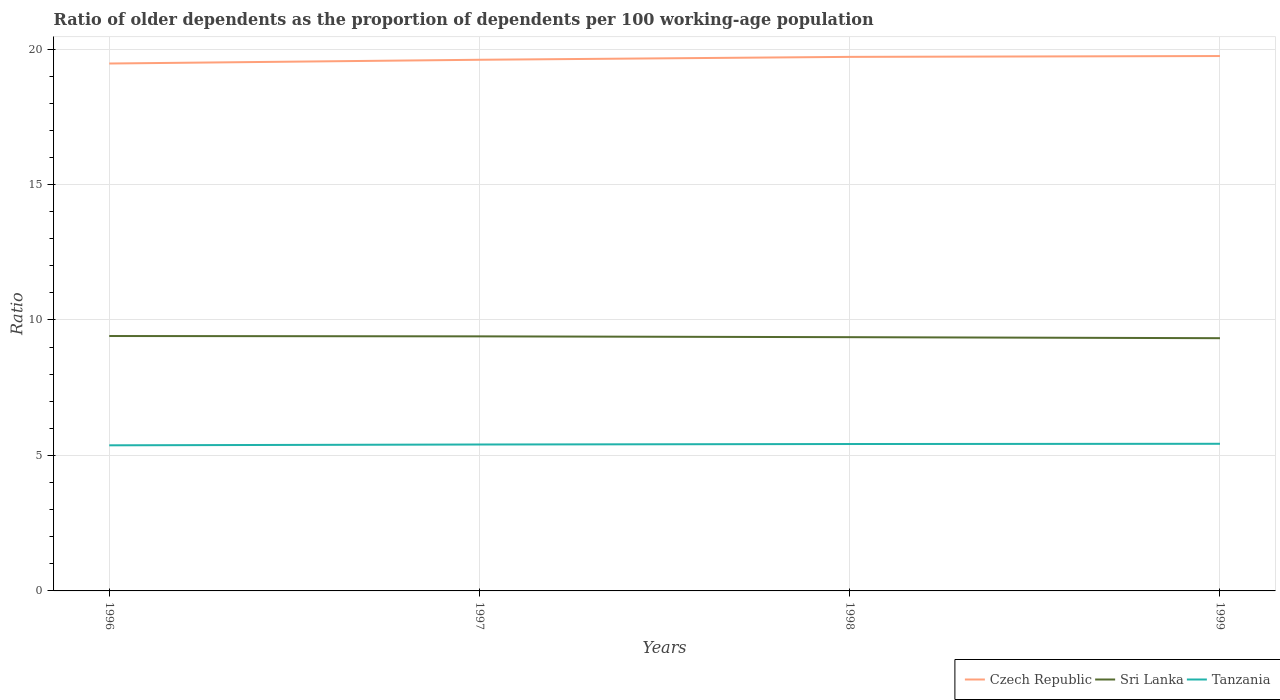How many different coloured lines are there?
Your answer should be very brief. 3. Is the number of lines equal to the number of legend labels?
Your answer should be compact. Yes. Across all years, what is the maximum age dependency ratio(old) in Sri Lanka?
Your answer should be compact. 9.33. What is the total age dependency ratio(old) in Sri Lanka in the graph?
Give a very brief answer. 0.04. What is the difference between the highest and the second highest age dependency ratio(old) in Tanzania?
Provide a short and direct response. 0.06. How many years are there in the graph?
Offer a very short reply. 4. What is the difference between two consecutive major ticks on the Y-axis?
Offer a terse response. 5. Are the values on the major ticks of Y-axis written in scientific E-notation?
Give a very brief answer. No. Does the graph contain any zero values?
Make the answer very short. No. How many legend labels are there?
Ensure brevity in your answer.  3. How are the legend labels stacked?
Provide a succinct answer. Horizontal. What is the title of the graph?
Keep it short and to the point. Ratio of older dependents as the proportion of dependents per 100 working-age population. What is the label or title of the X-axis?
Your response must be concise. Years. What is the label or title of the Y-axis?
Offer a very short reply. Ratio. What is the Ratio of Czech Republic in 1996?
Keep it short and to the point. 19.47. What is the Ratio in Sri Lanka in 1996?
Ensure brevity in your answer.  9.41. What is the Ratio in Tanzania in 1996?
Make the answer very short. 5.37. What is the Ratio of Czech Republic in 1997?
Make the answer very short. 19.6. What is the Ratio in Sri Lanka in 1997?
Your response must be concise. 9.4. What is the Ratio in Tanzania in 1997?
Your answer should be very brief. 5.4. What is the Ratio of Czech Republic in 1998?
Your answer should be compact. 19.71. What is the Ratio in Sri Lanka in 1998?
Offer a terse response. 9.37. What is the Ratio of Tanzania in 1998?
Your answer should be compact. 5.42. What is the Ratio in Czech Republic in 1999?
Provide a short and direct response. 19.74. What is the Ratio of Sri Lanka in 1999?
Your answer should be very brief. 9.33. What is the Ratio in Tanzania in 1999?
Provide a succinct answer. 5.43. Across all years, what is the maximum Ratio of Czech Republic?
Offer a terse response. 19.74. Across all years, what is the maximum Ratio of Sri Lanka?
Your response must be concise. 9.41. Across all years, what is the maximum Ratio in Tanzania?
Your answer should be very brief. 5.43. Across all years, what is the minimum Ratio in Czech Republic?
Your answer should be very brief. 19.47. Across all years, what is the minimum Ratio of Sri Lanka?
Offer a terse response. 9.33. Across all years, what is the minimum Ratio in Tanzania?
Ensure brevity in your answer.  5.37. What is the total Ratio in Czech Republic in the graph?
Give a very brief answer. 78.52. What is the total Ratio of Sri Lanka in the graph?
Your answer should be compact. 37.5. What is the total Ratio in Tanzania in the graph?
Give a very brief answer. 21.63. What is the difference between the Ratio of Czech Republic in 1996 and that in 1997?
Your answer should be compact. -0.14. What is the difference between the Ratio of Sri Lanka in 1996 and that in 1997?
Your answer should be very brief. 0.01. What is the difference between the Ratio in Tanzania in 1996 and that in 1997?
Your answer should be compact. -0.03. What is the difference between the Ratio in Czech Republic in 1996 and that in 1998?
Offer a terse response. -0.24. What is the difference between the Ratio in Sri Lanka in 1996 and that in 1998?
Your answer should be compact. 0.04. What is the difference between the Ratio in Tanzania in 1996 and that in 1998?
Provide a succinct answer. -0.05. What is the difference between the Ratio in Czech Republic in 1996 and that in 1999?
Make the answer very short. -0.28. What is the difference between the Ratio of Sri Lanka in 1996 and that in 1999?
Your answer should be compact. 0.08. What is the difference between the Ratio in Tanzania in 1996 and that in 1999?
Your answer should be very brief. -0.06. What is the difference between the Ratio in Czech Republic in 1997 and that in 1998?
Offer a very short reply. -0.11. What is the difference between the Ratio of Sri Lanka in 1997 and that in 1998?
Make the answer very short. 0.03. What is the difference between the Ratio of Tanzania in 1997 and that in 1998?
Give a very brief answer. -0.02. What is the difference between the Ratio of Czech Republic in 1997 and that in 1999?
Provide a succinct answer. -0.14. What is the difference between the Ratio of Sri Lanka in 1997 and that in 1999?
Make the answer very short. 0.07. What is the difference between the Ratio in Tanzania in 1997 and that in 1999?
Offer a very short reply. -0.03. What is the difference between the Ratio of Czech Republic in 1998 and that in 1999?
Make the answer very short. -0.03. What is the difference between the Ratio of Sri Lanka in 1998 and that in 1999?
Make the answer very short. 0.04. What is the difference between the Ratio of Tanzania in 1998 and that in 1999?
Your answer should be compact. -0.01. What is the difference between the Ratio in Czech Republic in 1996 and the Ratio in Sri Lanka in 1997?
Your response must be concise. 10.07. What is the difference between the Ratio of Czech Republic in 1996 and the Ratio of Tanzania in 1997?
Make the answer very short. 14.06. What is the difference between the Ratio in Sri Lanka in 1996 and the Ratio in Tanzania in 1997?
Provide a short and direct response. 4. What is the difference between the Ratio in Czech Republic in 1996 and the Ratio in Sri Lanka in 1998?
Ensure brevity in your answer.  10.1. What is the difference between the Ratio of Czech Republic in 1996 and the Ratio of Tanzania in 1998?
Offer a terse response. 14.04. What is the difference between the Ratio in Sri Lanka in 1996 and the Ratio in Tanzania in 1998?
Your answer should be very brief. 3.99. What is the difference between the Ratio of Czech Republic in 1996 and the Ratio of Sri Lanka in 1999?
Ensure brevity in your answer.  10.14. What is the difference between the Ratio of Czech Republic in 1996 and the Ratio of Tanzania in 1999?
Your answer should be compact. 14.03. What is the difference between the Ratio of Sri Lanka in 1996 and the Ratio of Tanzania in 1999?
Provide a short and direct response. 3.98. What is the difference between the Ratio in Czech Republic in 1997 and the Ratio in Sri Lanka in 1998?
Offer a terse response. 10.24. What is the difference between the Ratio of Czech Republic in 1997 and the Ratio of Tanzania in 1998?
Provide a short and direct response. 14.18. What is the difference between the Ratio of Sri Lanka in 1997 and the Ratio of Tanzania in 1998?
Offer a terse response. 3.97. What is the difference between the Ratio in Czech Republic in 1997 and the Ratio in Sri Lanka in 1999?
Offer a terse response. 10.28. What is the difference between the Ratio in Czech Republic in 1997 and the Ratio in Tanzania in 1999?
Your response must be concise. 14.17. What is the difference between the Ratio of Sri Lanka in 1997 and the Ratio of Tanzania in 1999?
Make the answer very short. 3.96. What is the difference between the Ratio of Czech Republic in 1998 and the Ratio of Sri Lanka in 1999?
Make the answer very short. 10.38. What is the difference between the Ratio of Czech Republic in 1998 and the Ratio of Tanzania in 1999?
Offer a very short reply. 14.28. What is the difference between the Ratio of Sri Lanka in 1998 and the Ratio of Tanzania in 1999?
Make the answer very short. 3.93. What is the average Ratio in Czech Republic per year?
Your answer should be compact. 19.63. What is the average Ratio in Sri Lanka per year?
Your answer should be very brief. 9.37. What is the average Ratio of Tanzania per year?
Offer a very short reply. 5.41. In the year 1996, what is the difference between the Ratio in Czech Republic and Ratio in Sri Lanka?
Your answer should be compact. 10.06. In the year 1996, what is the difference between the Ratio of Czech Republic and Ratio of Tanzania?
Make the answer very short. 14.09. In the year 1996, what is the difference between the Ratio of Sri Lanka and Ratio of Tanzania?
Provide a short and direct response. 4.03. In the year 1997, what is the difference between the Ratio of Czech Republic and Ratio of Sri Lanka?
Give a very brief answer. 10.21. In the year 1997, what is the difference between the Ratio in Czech Republic and Ratio in Tanzania?
Keep it short and to the point. 14.2. In the year 1997, what is the difference between the Ratio in Sri Lanka and Ratio in Tanzania?
Offer a terse response. 3.99. In the year 1998, what is the difference between the Ratio in Czech Republic and Ratio in Sri Lanka?
Give a very brief answer. 10.35. In the year 1998, what is the difference between the Ratio of Czech Republic and Ratio of Tanzania?
Offer a terse response. 14.29. In the year 1998, what is the difference between the Ratio of Sri Lanka and Ratio of Tanzania?
Give a very brief answer. 3.94. In the year 1999, what is the difference between the Ratio in Czech Republic and Ratio in Sri Lanka?
Give a very brief answer. 10.41. In the year 1999, what is the difference between the Ratio of Czech Republic and Ratio of Tanzania?
Make the answer very short. 14.31. In the year 1999, what is the difference between the Ratio of Sri Lanka and Ratio of Tanzania?
Offer a terse response. 3.9. What is the ratio of the Ratio of Sri Lanka in 1996 to that in 1997?
Your answer should be compact. 1. What is the ratio of the Ratio of Czech Republic in 1996 to that in 1998?
Offer a terse response. 0.99. What is the ratio of the Ratio of Sri Lanka in 1996 to that in 1999?
Keep it short and to the point. 1.01. What is the ratio of the Ratio in Tanzania in 1997 to that in 1998?
Ensure brevity in your answer.  1. What is the ratio of the Ratio of Czech Republic in 1997 to that in 1999?
Offer a very short reply. 0.99. What is the ratio of the Ratio in Sri Lanka in 1997 to that in 1999?
Ensure brevity in your answer.  1.01. What is the ratio of the Ratio in Tanzania in 1997 to that in 1999?
Provide a short and direct response. 0.99. What is the ratio of the Ratio in Czech Republic in 1998 to that in 1999?
Your answer should be very brief. 1. What is the ratio of the Ratio of Sri Lanka in 1998 to that in 1999?
Offer a very short reply. 1. What is the difference between the highest and the second highest Ratio in Czech Republic?
Provide a short and direct response. 0.03. What is the difference between the highest and the second highest Ratio in Sri Lanka?
Your answer should be very brief. 0.01. What is the difference between the highest and the second highest Ratio of Tanzania?
Offer a terse response. 0.01. What is the difference between the highest and the lowest Ratio in Czech Republic?
Make the answer very short. 0.28. What is the difference between the highest and the lowest Ratio in Sri Lanka?
Provide a succinct answer. 0.08. What is the difference between the highest and the lowest Ratio of Tanzania?
Ensure brevity in your answer.  0.06. 